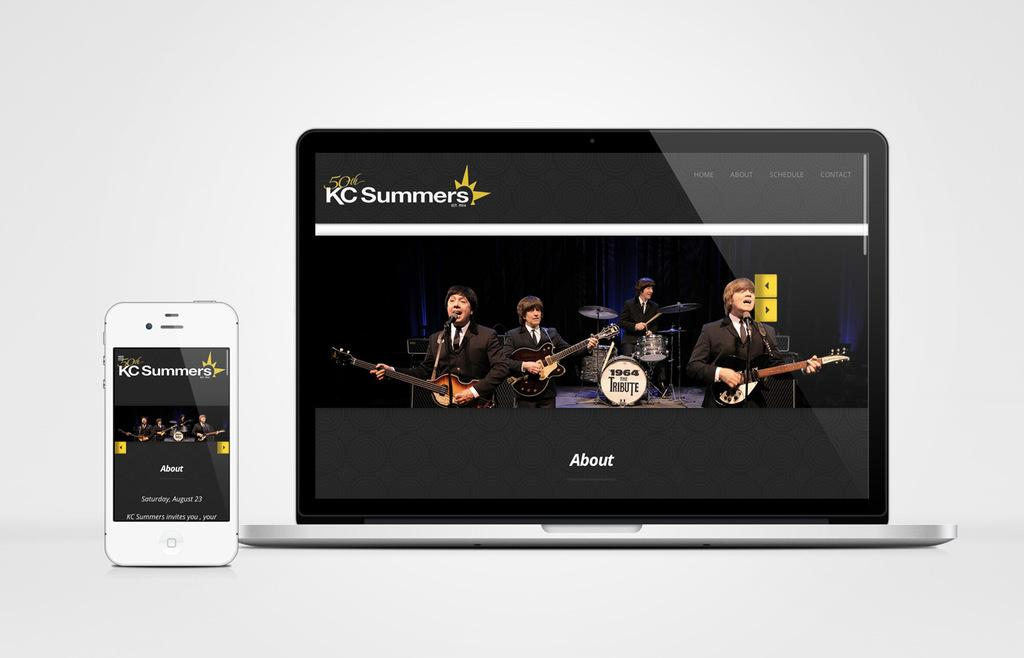<image>
Relay a brief, clear account of the picture shown. Beside the laptop with a band of musicians on the screen, is an iphone and they both say KC Summers. 